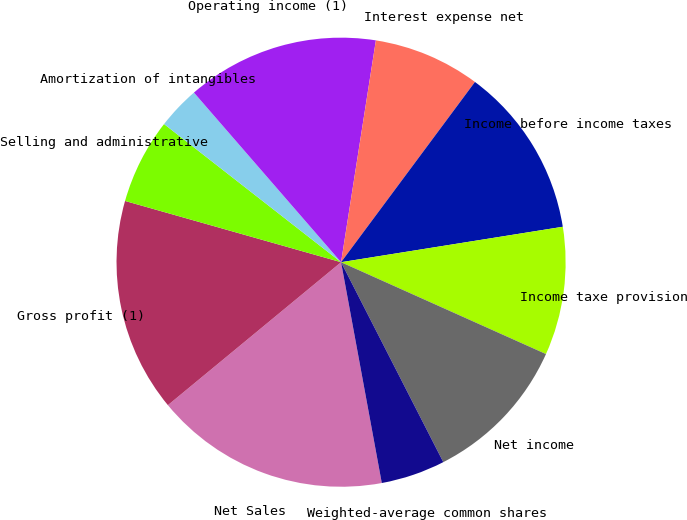Convert chart. <chart><loc_0><loc_0><loc_500><loc_500><pie_chart><fcel>Net Sales<fcel>Gross profit (1)<fcel>Selling and administrative<fcel>Amortization of intangibles<fcel>Operating income (1)<fcel>Interest expense net<fcel>Income before income taxes<fcel>Income taxe provision<fcel>Net income<fcel>Weighted-average common shares<nl><fcel>16.92%<fcel>15.38%<fcel>6.15%<fcel>3.08%<fcel>13.85%<fcel>7.69%<fcel>12.31%<fcel>9.23%<fcel>10.77%<fcel>4.62%<nl></chart> 